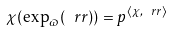Convert formula to latex. <formula><loc_0><loc_0><loc_500><loc_500>\chi ( \exp _ { \varpi } ( \ r r ) ) = p ^ { \langle \chi , \ r r \rangle }</formula> 